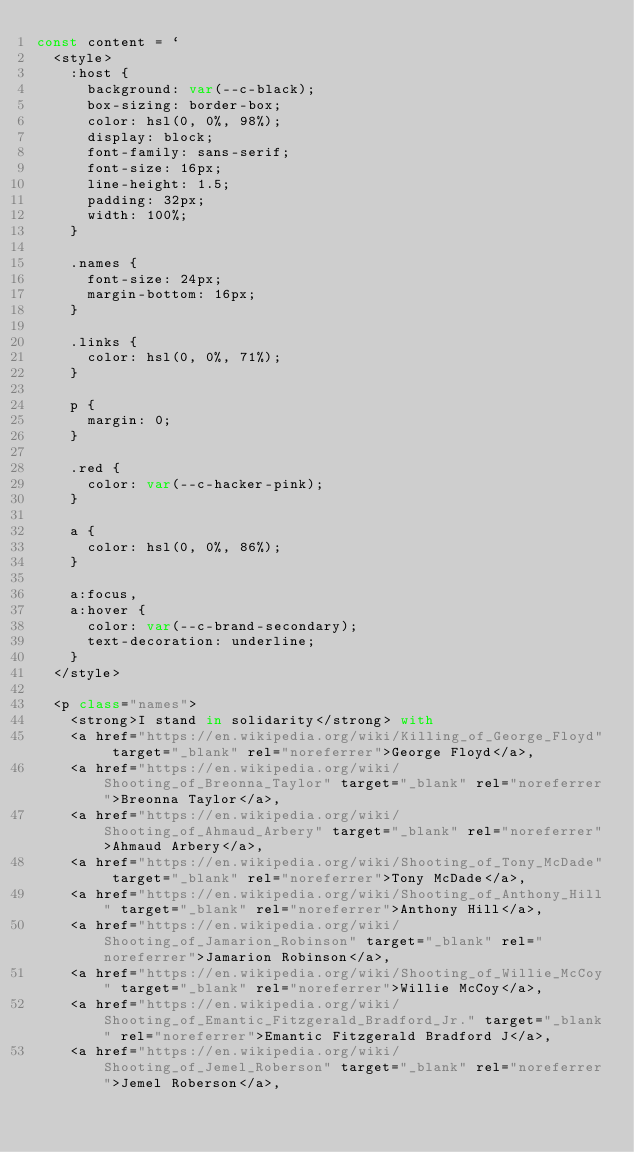Convert code to text. <code><loc_0><loc_0><loc_500><loc_500><_JavaScript_>const content = `
  <style>
    :host {
      background: var(--c-black);
      box-sizing: border-box;
      color: hsl(0, 0%, 98%);
      display: block;
      font-family: sans-serif;
      font-size: 16px;
      line-height: 1.5;
      padding: 32px;
      width: 100%;
    }

    .names {
      font-size: 24px;
      margin-bottom: 16px;
    }

    .links {
      color: hsl(0, 0%, 71%);
    }

    p {
      margin: 0;
    }

    .red {
      color: var(--c-hacker-pink);
    }

    a {
      color: hsl(0, 0%, 86%);
    }

    a:focus,
    a:hover {
      color: var(--c-brand-secondary);
      text-decoration: underline;
    }
  </style>

  <p class="names">
    <strong>I stand in solidarity</strong> with
    <a href="https://en.wikipedia.org/wiki/Killing_of_George_Floyd" target="_blank" rel="noreferrer">George Floyd</a>,
    <a href="https://en.wikipedia.org/wiki/Shooting_of_Breonna_Taylor" target="_blank" rel="noreferrer">Breonna Taylor</a>,
    <a href="https://en.wikipedia.org/wiki/Shooting_of_Ahmaud_Arbery" target="_blank" rel="noreferrer">Ahmaud Arbery</a>,
    <a href="https://en.wikipedia.org/wiki/Shooting_of_Tony_McDade" target="_blank" rel="noreferrer">Tony McDade</a>,
    <a href="https://en.wikipedia.org/wiki/Shooting_of_Anthony_Hill" target="_blank" rel="noreferrer">Anthony Hill</a>,
    <a href="https://en.wikipedia.org/wiki/Shooting_of_Jamarion_Robinson" target="_blank" rel="noreferrer">Jamarion Robinson</a>,
    <a href="https://en.wikipedia.org/wiki/Shooting_of_Willie_McCoy" target="_blank" rel="noreferrer">Willie McCoy</a>,
    <a href="https://en.wikipedia.org/wiki/Shooting_of_Emantic_Fitzgerald_Bradford_Jr." target="_blank" rel="noreferrer">Emantic Fitzgerald Bradford J</a>,
    <a href="https://en.wikipedia.org/wiki/Shooting_of_Jemel_Roberson" target="_blank" rel="noreferrer">Jemel Roberson</a>,</code> 